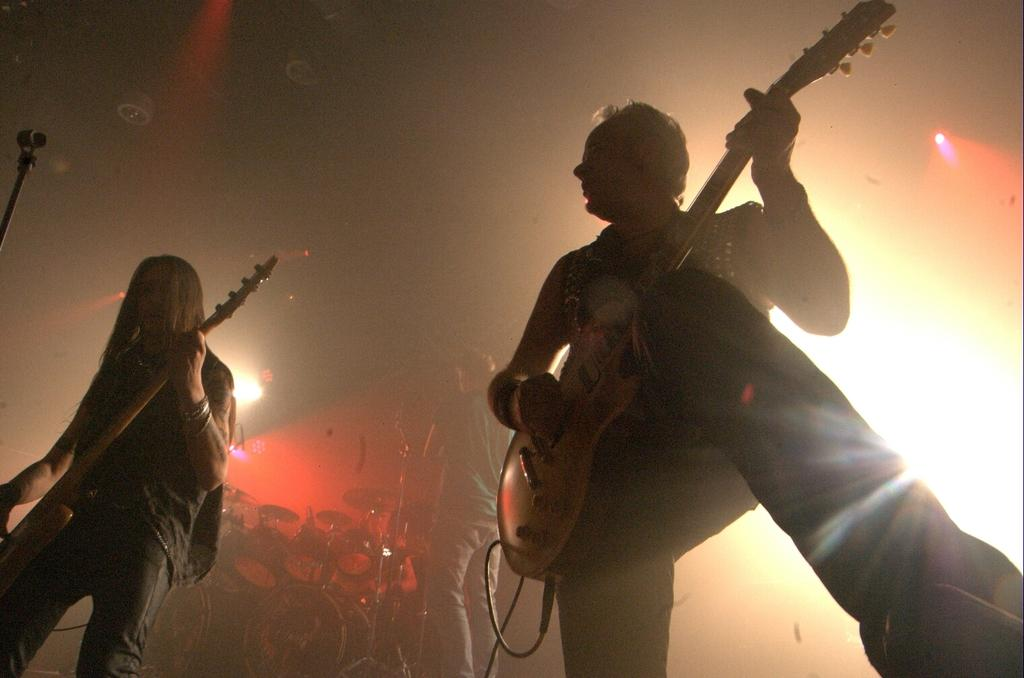How many people are in the image? There are three persons in the image. What is one of the persons holding? One of the persons is holding a guitar. Can you describe the musical instrument at the middle bottom of the image? There is a musical instrument at the middle bottom of the image, but its specific type is not mentioned in the facts. What can be seen at the top of the image? There are lights visible at the top of the image. What type of pail is being used to collect tomatoes in the image? There is no pail or tomatoes present in the image. How many tomatoes are visible in the image? There are no tomatoes present in the image. 